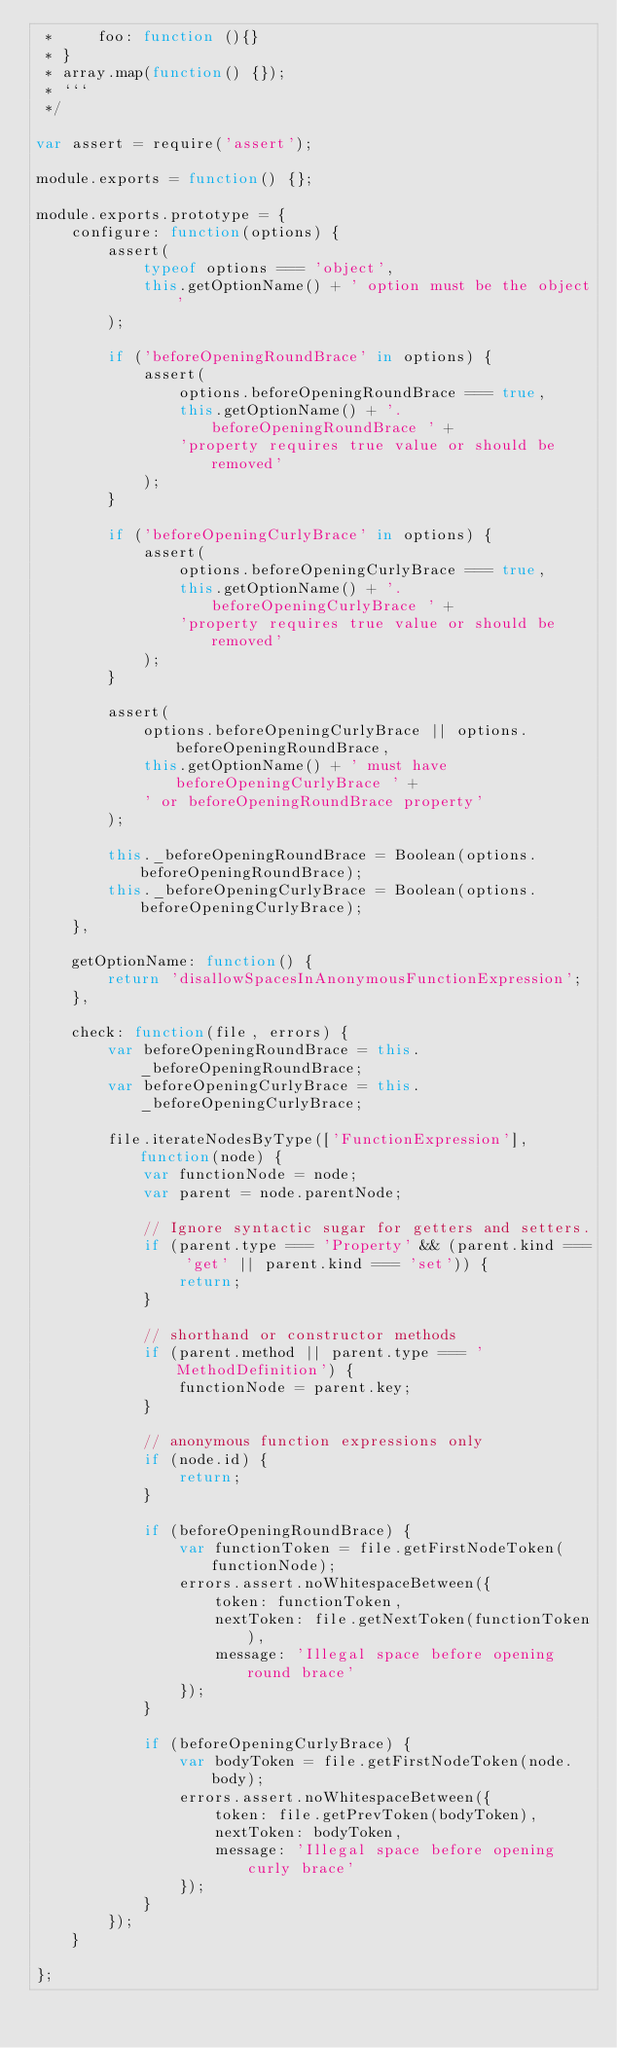Convert code to text. <code><loc_0><loc_0><loc_500><loc_500><_JavaScript_> *     foo: function (){}
 * }
 * array.map(function() {});
 * ```
 */

var assert = require('assert');

module.exports = function() {};

module.exports.prototype = {
    configure: function(options) {
        assert(
            typeof options === 'object',
            this.getOptionName() + ' option must be the object'
        );

        if ('beforeOpeningRoundBrace' in options) {
            assert(
                options.beforeOpeningRoundBrace === true,
                this.getOptionName() + '.beforeOpeningRoundBrace ' +
                'property requires true value or should be removed'
            );
        }

        if ('beforeOpeningCurlyBrace' in options) {
            assert(
                options.beforeOpeningCurlyBrace === true,
                this.getOptionName() + '.beforeOpeningCurlyBrace ' +
                'property requires true value or should be removed'
            );
        }

        assert(
            options.beforeOpeningCurlyBrace || options.beforeOpeningRoundBrace,
            this.getOptionName() + ' must have beforeOpeningCurlyBrace ' +
            ' or beforeOpeningRoundBrace property'
        );

        this._beforeOpeningRoundBrace = Boolean(options.beforeOpeningRoundBrace);
        this._beforeOpeningCurlyBrace = Boolean(options.beforeOpeningCurlyBrace);
    },

    getOptionName: function() {
        return 'disallowSpacesInAnonymousFunctionExpression';
    },

    check: function(file, errors) {
        var beforeOpeningRoundBrace = this._beforeOpeningRoundBrace;
        var beforeOpeningCurlyBrace = this._beforeOpeningCurlyBrace;

        file.iterateNodesByType(['FunctionExpression'], function(node) {
            var functionNode = node;
            var parent = node.parentNode;

            // Ignore syntactic sugar for getters and setters.
            if (parent.type === 'Property' && (parent.kind === 'get' || parent.kind === 'set')) {
                return;
            }

            // shorthand or constructor methods
            if (parent.method || parent.type === 'MethodDefinition') {
                functionNode = parent.key;
            }

            // anonymous function expressions only
            if (node.id) {
                return;
            }

            if (beforeOpeningRoundBrace) {
                var functionToken = file.getFirstNodeToken(functionNode);
                errors.assert.noWhitespaceBetween({
                    token: functionToken,
                    nextToken: file.getNextToken(functionToken),
                    message: 'Illegal space before opening round brace'
                });
            }

            if (beforeOpeningCurlyBrace) {
                var bodyToken = file.getFirstNodeToken(node.body);
                errors.assert.noWhitespaceBetween({
                    token: file.getPrevToken(bodyToken),
                    nextToken: bodyToken,
                    message: 'Illegal space before opening curly brace'
                });
            }
        });
    }

};
</code> 